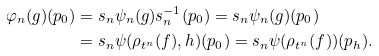Convert formula to latex. <formula><loc_0><loc_0><loc_500><loc_500>\varphi _ { n } ( g ) ( p _ { 0 } ) & = s _ { n } \psi _ { n } ( g ) s _ { n } ^ { - 1 } ( p _ { 0 } ) = s _ { n } \psi _ { n } ( g ) ( p _ { 0 } ) \\ & = s _ { n } \psi ( \rho _ { t ^ { n } } ( f ) , h ) ( p _ { 0 } ) = s _ { n } \psi ( \rho _ { t ^ { n } } ( f ) ) ( p _ { h } ) .</formula> 